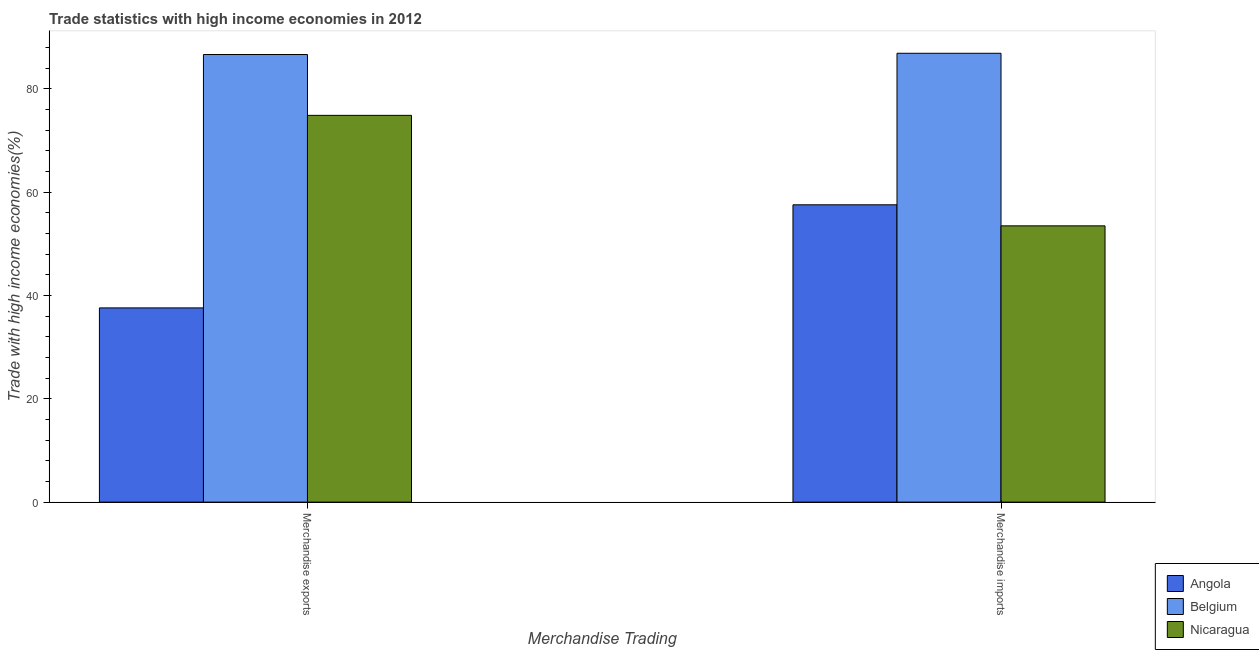How many groups of bars are there?
Provide a short and direct response. 2. What is the merchandise exports in Belgium?
Ensure brevity in your answer.  86.61. Across all countries, what is the maximum merchandise imports?
Keep it short and to the point. 86.86. Across all countries, what is the minimum merchandise imports?
Offer a terse response. 53.46. In which country was the merchandise imports maximum?
Your response must be concise. Belgium. In which country was the merchandise imports minimum?
Your response must be concise. Nicaragua. What is the total merchandise exports in the graph?
Keep it short and to the point. 199.04. What is the difference between the merchandise imports in Belgium and that in Nicaragua?
Offer a terse response. 33.4. What is the difference between the merchandise imports in Nicaragua and the merchandise exports in Angola?
Your response must be concise. 15.88. What is the average merchandise imports per country?
Provide a short and direct response. 65.95. What is the difference between the merchandise imports and merchandise exports in Belgium?
Offer a terse response. 0.24. What is the ratio of the merchandise exports in Angola to that in Belgium?
Keep it short and to the point. 0.43. What does the 3rd bar from the left in Merchandise exports represents?
Offer a very short reply. Nicaragua. What does the 1st bar from the right in Merchandise imports represents?
Offer a terse response. Nicaragua. How many bars are there?
Your response must be concise. 6. What is the difference between two consecutive major ticks on the Y-axis?
Offer a very short reply. 20. Does the graph contain any zero values?
Your response must be concise. No. Does the graph contain grids?
Make the answer very short. No. Where does the legend appear in the graph?
Provide a succinct answer. Bottom right. How many legend labels are there?
Your answer should be very brief. 3. What is the title of the graph?
Ensure brevity in your answer.  Trade statistics with high income economies in 2012. Does "Bhutan" appear as one of the legend labels in the graph?
Your answer should be very brief. No. What is the label or title of the X-axis?
Ensure brevity in your answer.  Merchandise Trading. What is the label or title of the Y-axis?
Your answer should be very brief. Trade with high income economies(%). What is the Trade with high income economies(%) in Angola in Merchandise exports?
Your answer should be compact. 37.58. What is the Trade with high income economies(%) in Belgium in Merchandise exports?
Give a very brief answer. 86.61. What is the Trade with high income economies(%) in Nicaragua in Merchandise exports?
Offer a very short reply. 74.84. What is the Trade with high income economies(%) of Angola in Merchandise imports?
Give a very brief answer. 57.53. What is the Trade with high income economies(%) in Belgium in Merchandise imports?
Provide a short and direct response. 86.86. What is the Trade with high income economies(%) in Nicaragua in Merchandise imports?
Provide a short and direct response. 53.46. Across all Merchandise Trading, what is the maximum Trade with high income economies(%) of Angola?
Your answer should be compact. 57.53. Across all Merchandise Trading, what is the maximum Trade with high income economies(%) of Belgium?
Your answer should be very brief. 86.86. Across all Merchandise Trading, what is the maximum Trade with high income economies(%) of Nicaragua?
Provide a short and direct response. 74.84. Across all Merchandise Trading, what is the minimum Trade with high income economies(%) in Angola?
Your answer should be very brief. 37.58. Across all Merchandise Trading, what is the minimum Trade with high income economies(%) in Belgium?
Make the answer very short. 86.61. Across all Merchandise Trading, what is the minimum Trade with high income economies(%) of Nicaragua?
Offer a very short reply. 53.46. What is the total Trade with high income economies(%) of Angola in the graph?
Offer a terse response. 95.12. What is the total Trade with high income economies(%) of Belgium in the graph?
Keep it short and to the point. 173.47. What is the total Trade with high income economies(%) of Nicaragua in the graph?
Keep it short and to the point. 128.31. What is the difference between the Trade with high income economies(%) of Angola in Merchandise exports and that in Merchandise imports?
Your answer should be compact. -19.95. What is the difference between the Trade with high income economies(%) in Belgium in Merchandise exports and that in Merchandise imports?
Your response must be concise. -0.24. What is the difference between the Trade with high income economies(%) in Nicaragua in Merchandise exports and that in Merchandise imports?
Your answer should be compact. 21.38. What is the difference between the Trade with high income economies(%) of Angola in Merchandise exports and the Trade with high income economies(%) of Belgium in Merchandise imports?
Offer a very short reply. -49.27. What is the difference between the Trade with high income economies(%) of Angola in Merchandise exports and the Trade with high income economies(%) of Nicaragua in Merchandise imports?
Keep it short and to the point. -15.88. What is the difference between the Trade with high income economies(%) of Belgium in Merchandise exports and the Trade with high income economies(%) of Nicaragua in Merchandise imports?
Keep it short and to the point. 33.15. What is the average Trade with high income economies(%) of Angola per Merchandise Trading?
Give a very brief answer. 47.56. What is the average Trade with high income economies(%) of Belgium per Merchandise Trading?
Provide a short and direct response. 86.74. What is the average Trade with high income economies(%) of Nicaragua per Merchandise Trading?
Your answer should be compact. 64.15. What is the difference between the Trade with high income economies(%) of Angola and Trade with high income economies(%) of Belgium in Merchandise exports?
Make the answer very short. -49.03. What is the difference between the Trade with high income economies(%) in Angola and Trade with high income economies(%) in Nicaragua in Merchandise exports?
Keep it short and to the point. -37.26. What is the difference between the Trade with high income economies(%) of Belgium and Trade with high income economies(%) of Nicaragua in Merchandise exports?
Your answer should be compact. 11.77. What is the difference between the Trade with high income economies(%) of Angola and Trade with high income economies(%) of Belgium in Merchandise imports?
Give a very brief answer. -29.32. What is the difference between the Trade with high income economies(%) in Angola and Trade with high income economies(%) in Nicaragua in Merchandise imports?
Offer a terse response. 4.07. What is the difference between the Trade with high income economies(%) in Belgium and Trade with high income economies(%) in Nicaragua in Merchandise imports?
Keep it short and to the point. 33.4. What is the ratio of the Trade with high income economies(%) in Angola in Merchandise exports to that in Merchandise imports?
Give a very brief answer. 0.65. What is the ratio of the Trade with high income economies(%) of Nicaragua in Merchandise exports to that in Merchandise imports?
Make the answer very short. 1.4. What is the difference between the highest and the second highest Trade with high income economies(%) in Angola?
Offer a terse response. 19.95. What is the difference between the highest and the second highest Trade with high income economies(%) in Belgium?
Offer a very short reply. 0.24. What is the difference between the highest and the second highest Trade with high income economies(%) in Nicaragua?
Your answer should be very brief. 21.38. What is the difference between the highest and the lowest Trade with high income economies(%) of Angola?
Make the answer very short. 19.95. What is the difference between the highest and the lowest Trade with high income economies(%) of Belgium?
Provide a succinct answer. 0.24. What is the difference between the highest and the lowest Trade with high income economies(%) of Nicaragua?
Your answer should be compact. 21.38. 